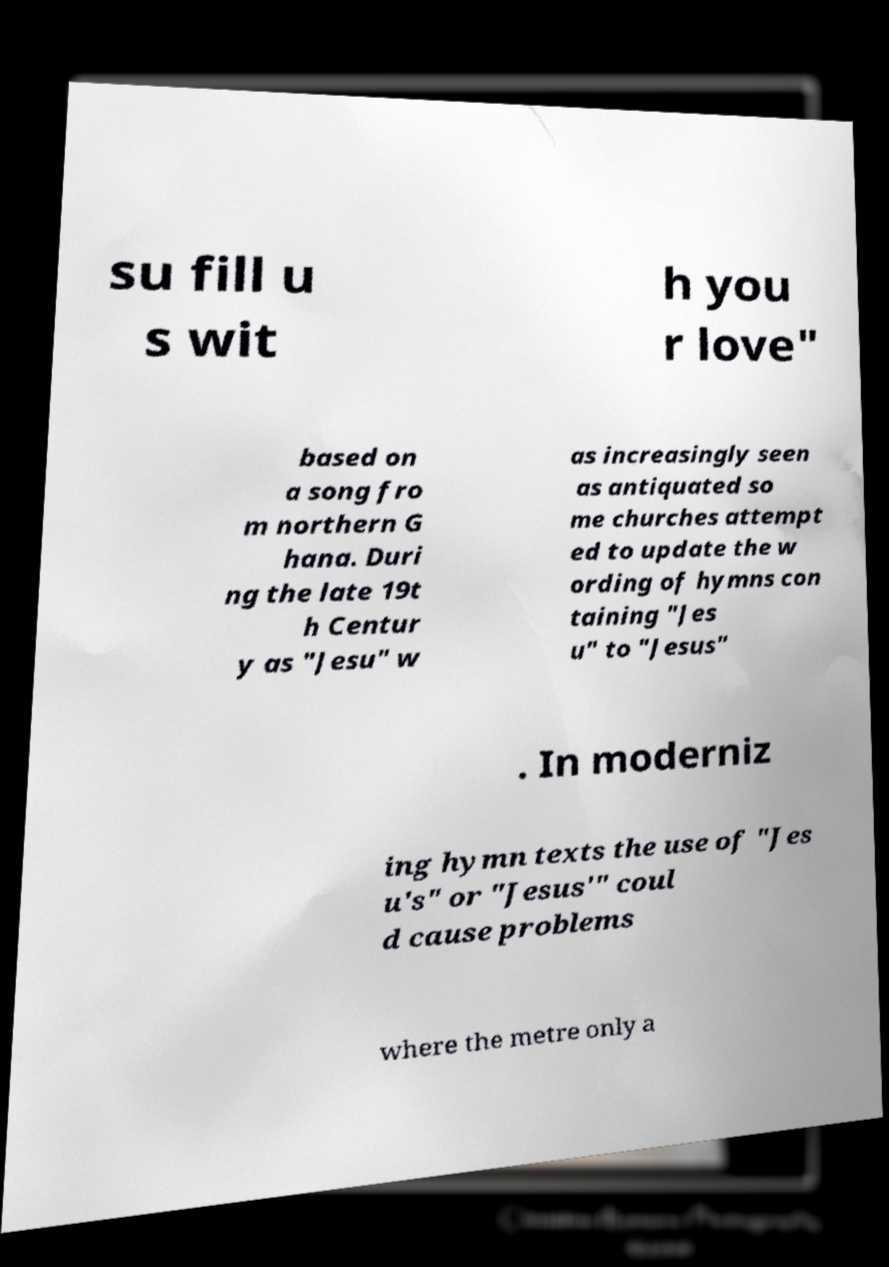Can you read and provide the text displayed in the image?This photo seems to have some interesting text. Can you extract and type it out for me? su fill u s wit h you r love" based on a song fro m northern G hana. Duri ng the late 19t h Centur y as "Jesu" w as increasingly seen as antiquated so me churches attempt ed to update the w ording of hymns con taining "Jes u" to "Jesus" . In moderniz ing hymn texts the use of "Jes u's" or "Jesus'" coul d cause problems where the metre only a 